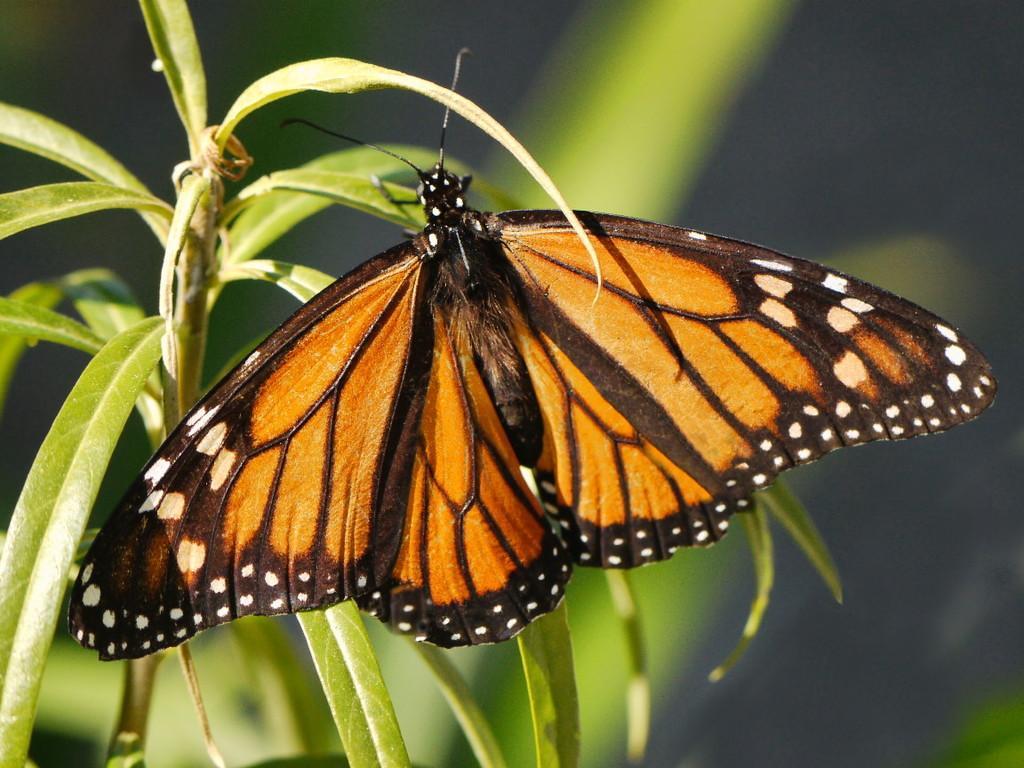Describe this image in one or two sentences. In this picture I can see a butterfly on the leaves. 